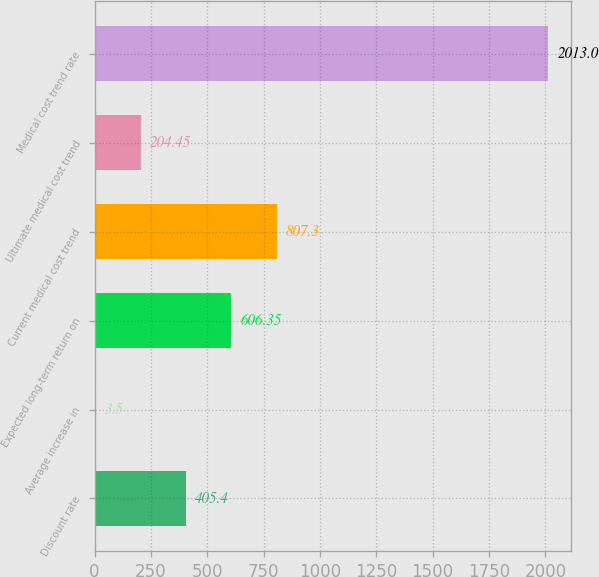<chart> <loc_0><loc_0><loc_500><loc_500><bar_chart><fcel>Discount rate<fcel>Average increase in<fcel>Expected long-term return on<fcel>Current medical cost trend<fcel>Ultimate medical cost trend<fcel>Medical cost trend rate<nl><fcel>405.4<fcel>3.5<fcel>606.35<fcel>807.3<fcel>204.45<fcel>2013<nl></chart> 